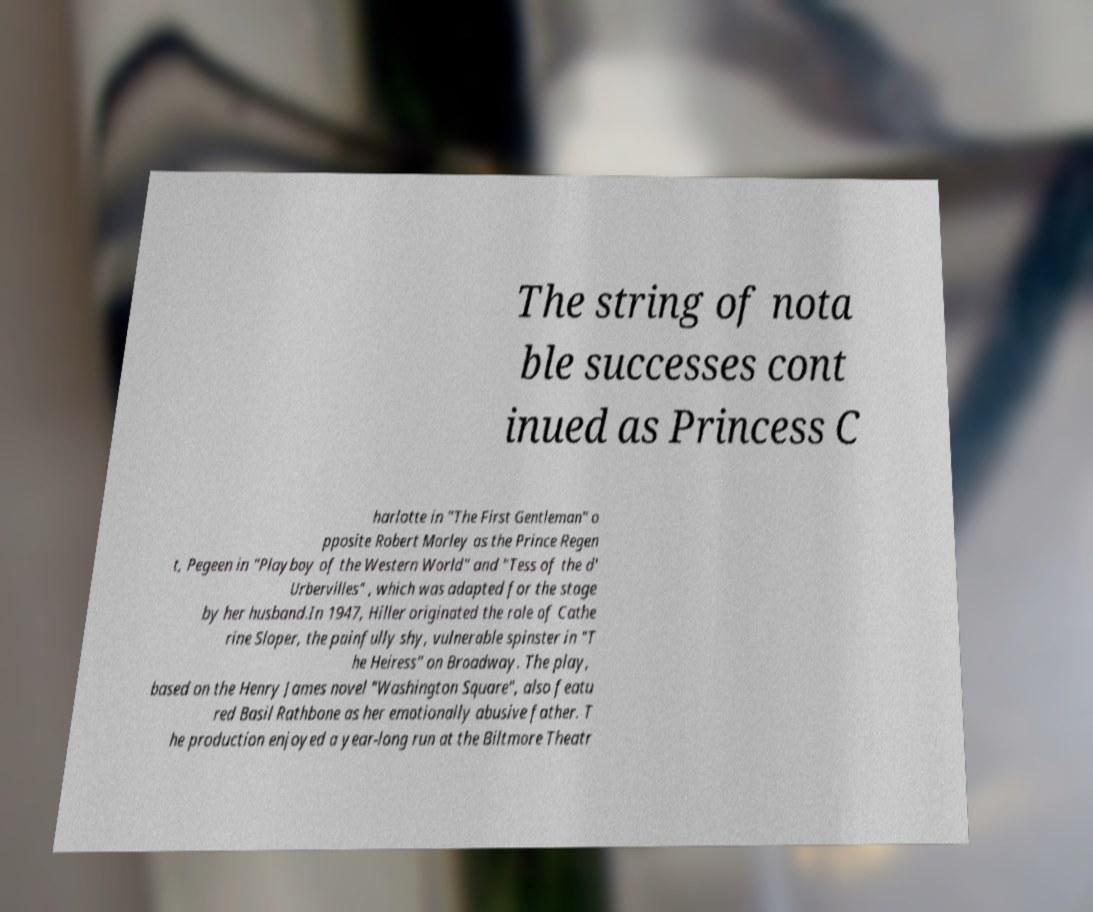Can you accurately transcribe the text from the provided image for me? The string of nota ble successes cont inued as Princess C harlotte in "The First Gentleman" o pposite Robert Morley as the Prince Regen t, Pegeen in "Playboy of the Western World" and "Tess of the d' Urbervilles" , which was adapted for the stage by her husband.In 1947, Hiller originated the role of Cathe rine Sloper, the painfully shy, vulnerable spinster in "T he Heiress" on Broadway. The play, based on the Henry James novel "Washington Square", also featu red Basil Rathbone as her emotionally abusive father. T he production enjoyed a year-long run at the Biltmore Theatr 